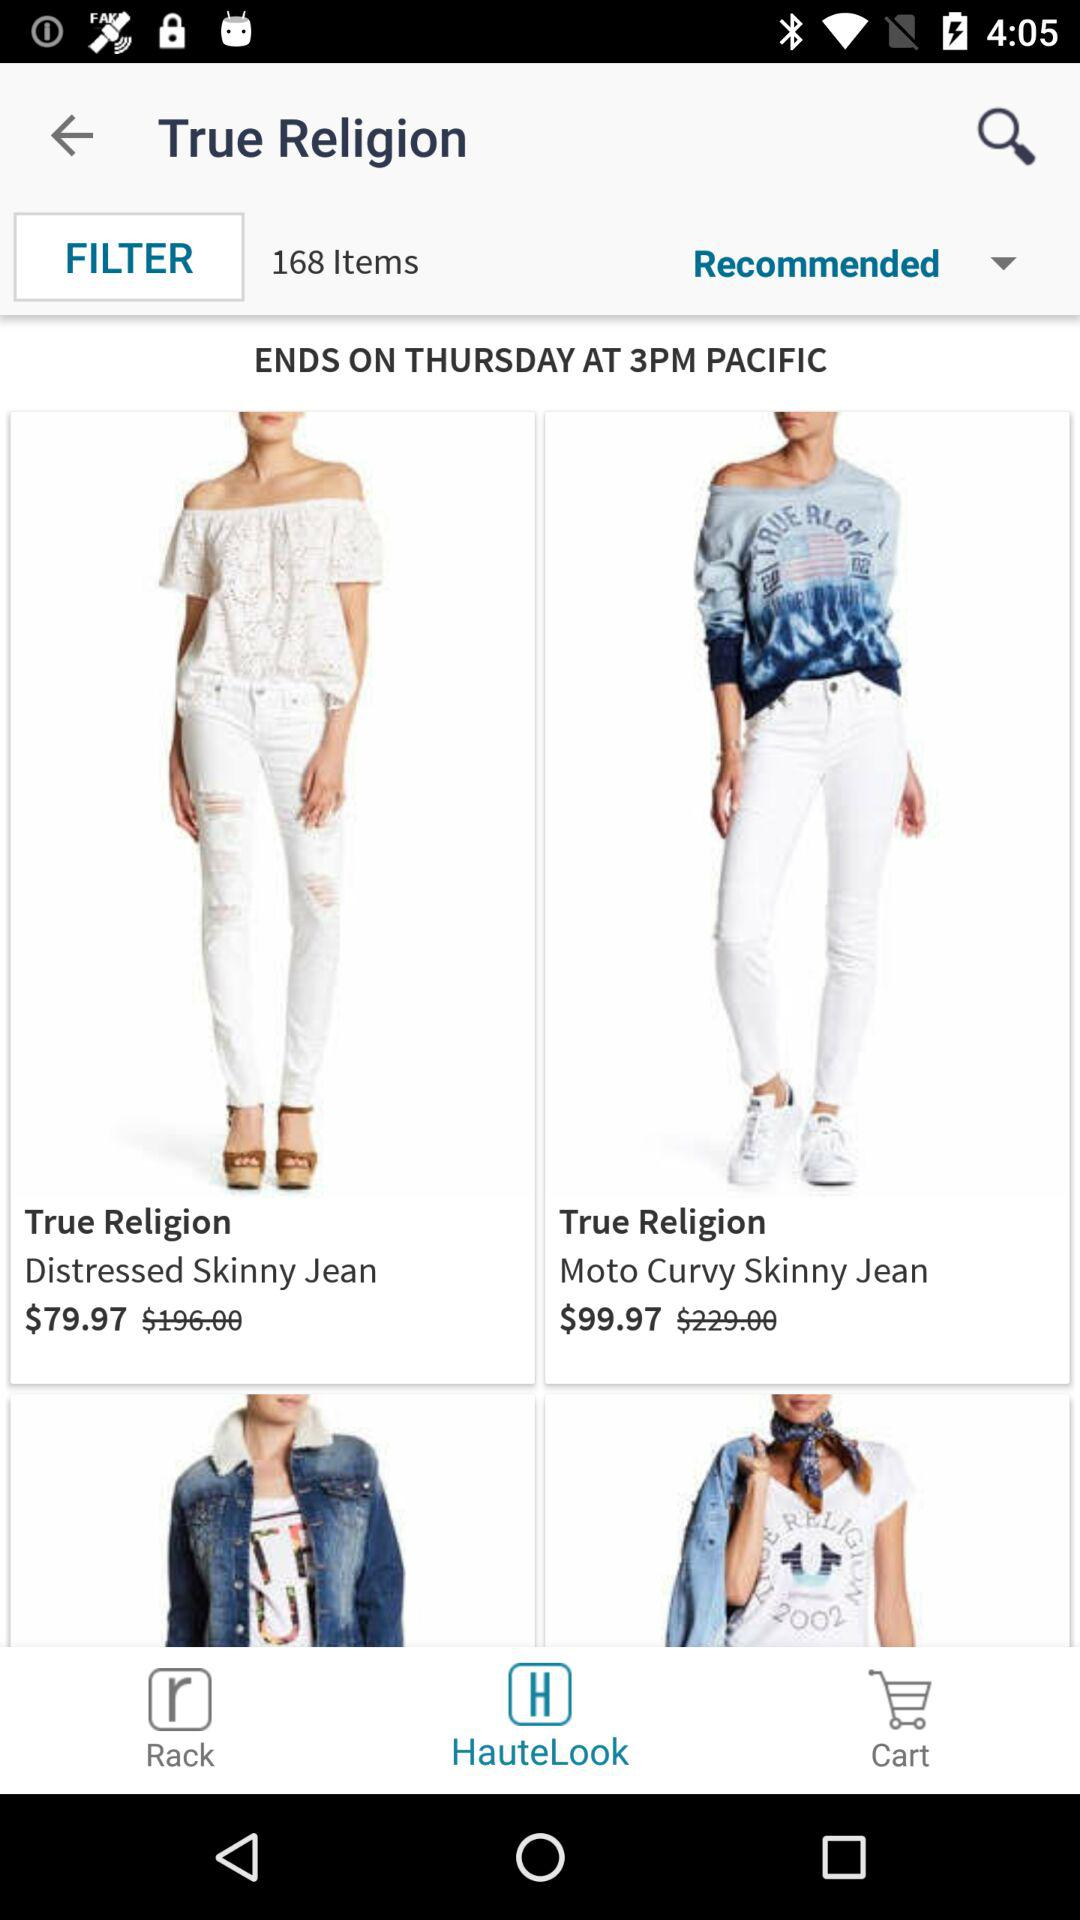Which tab is selected? The selected tab is "HauteLook". 